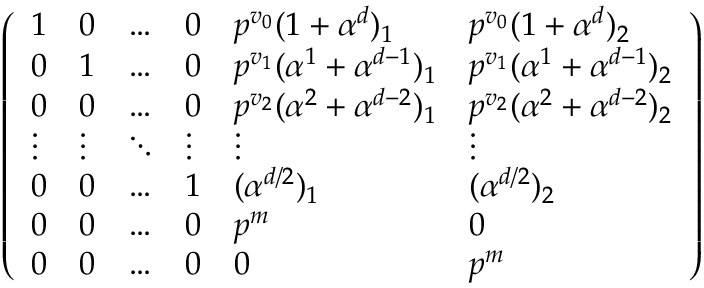Convert formula to latex. <formula><loc_0><loc_0><loc_500><loc_500>\left ( \begin{array} { l l l l l l } { 1 } & { 0 } & { \dots } & { 0 } & { p ^ { v _ { 0 } } ( 1 + \alpha ^ { d } ) _ { 1 } } & { p ^ { v _ { 0 } } ( 1 + \alpha ^ { d } ) _ { 2 } } \\ { 0 } & { 1 } & { \dots } & { 0 } & { p ^ { v _ { 1 } } ( \alpha ^ { 1 } + \alpha ^ { d - 1 } ) _ { 1 } } & { p ^ { v _ { 1 } } ( \alpha ^ { 1 } + \alpha ^ { d - 1 } ) _ { 2 } } \\ { 0 } & { 0 } & { \dots } & { 0 } & { p ^ { v _ { 2 } } ( \alpha ^ { 2 } + \alpha ^ { d - 2 } ) _ { 1 } } & { p ^ { v _ { 2 } } ( \alpha ^ { 2 } + \alpha ^ { d - 2 } ) _ { 2 } } \\ { \vdots } & { \vdots } & { \ddots } & { \vdots } & { \vdots } & { \vdots } \\ { 0 } & { 0 } & { \dots } & { 1 } & { ( \alpha ^ { d / 2 } ) _ { 1 } } & { ( \alpha ^ { d / 2 } ) _ { 2 } } \\ { 0 } & { 0 } & { \dots } & { 0 } & { p ^ { m } } & { 0 } \\ { 0 } & { 0 } & { \dots } & { 0 } & { 0 } & { p ^ { m } } \end{array} \right )</formula> 